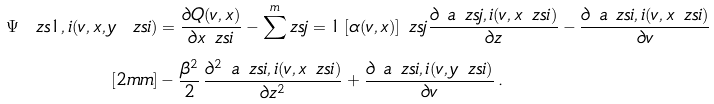Convert formula to latex. <formula><loc_0><loc_0><loc_500><loc_500>\Psi _ { \ } z s { 1 , i } ( v , x , y _ { \ } z s { i } ) & = \frac { \partial Q ( v , x ) } { \partial x _ { \ } z s { i } } - \sum ^ { m } _ { \ } z s { j = 1 } \, [ \alpha ( v , x ) ] _ { \ } z s { j } \frac { \partial \ a _ { \ } z s { j , i } ( v , x _ { \ } z s { i } ) } { \partial z } - \frac { \partial \ a _ { \ } z s { i , i } ( v , x _ { \ } z s { i } ) } { \partial v } \\ [ 2 m m ] & - \frac { \beta ^ { 2 } } { 2 } \, \frac { \partial ^ { 2 } \ a _ { \ } z s { i , i } ( v , x _ { \ } z s { i } ) } { \partial z ^ { 2 } } + \frac { \partial \ a _ { \ } z s { i , i } ( v , y _ { \ } z s { i } ) } { \partial v } \, .</formula> 